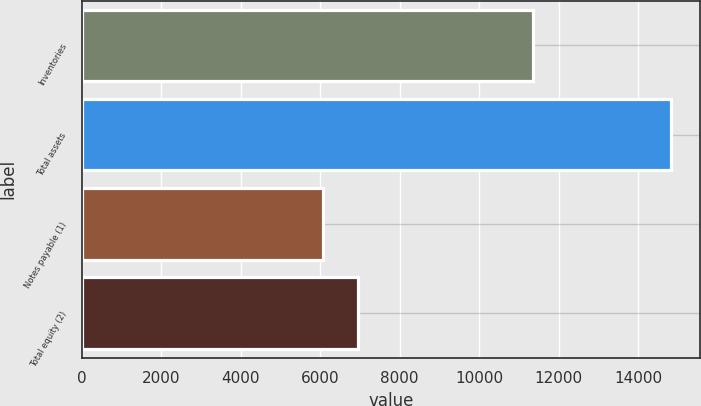Convert chart to OTSL. <chart><loc_0><loc_0><loc_500><loc_500><bar_chart><fcel>Inventories<fcel>Total assets<fcel>Notes payable (1)<fcel>Total equity (2)<nl><fcel>11343.1<fcel>14820.7<fcel>6078.6<fcel>6952.81<nl></chart> 